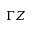Convert formula to latex. <formula><loc_0><loc_0><loc_500><loc_500>\Gamma Z</formula> 